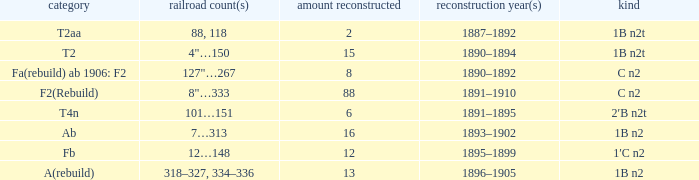What was the Rebuildjahr(e) for the T2AA class? 1887–1892. 